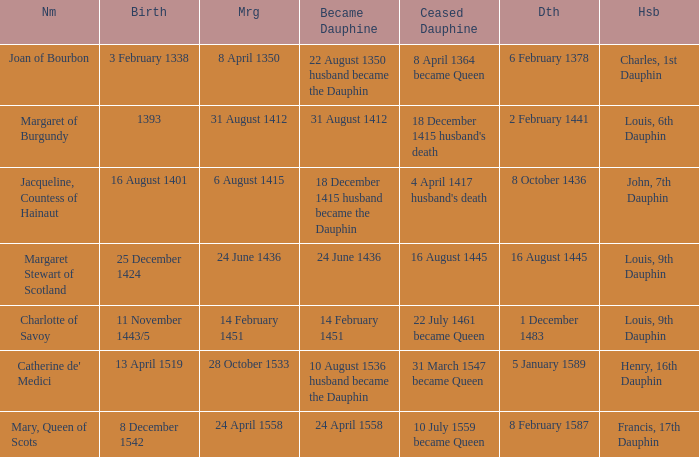When was the marriage when became dauphine is 31 august 1412? 31 August 1412. 